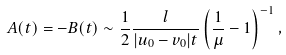Convert formula to latex. <formula><loc_0><loc_0><loc_500><loc_500>A ( t ) = - B ( t ) \sim \frac { 1 } { 2 } \frac { l } { | u _ { 0 } - v _ { 0 } | t } \left ( \frac { 1 } { \mu } - 1 \right ) ^ { - 1 } ,</formula> 